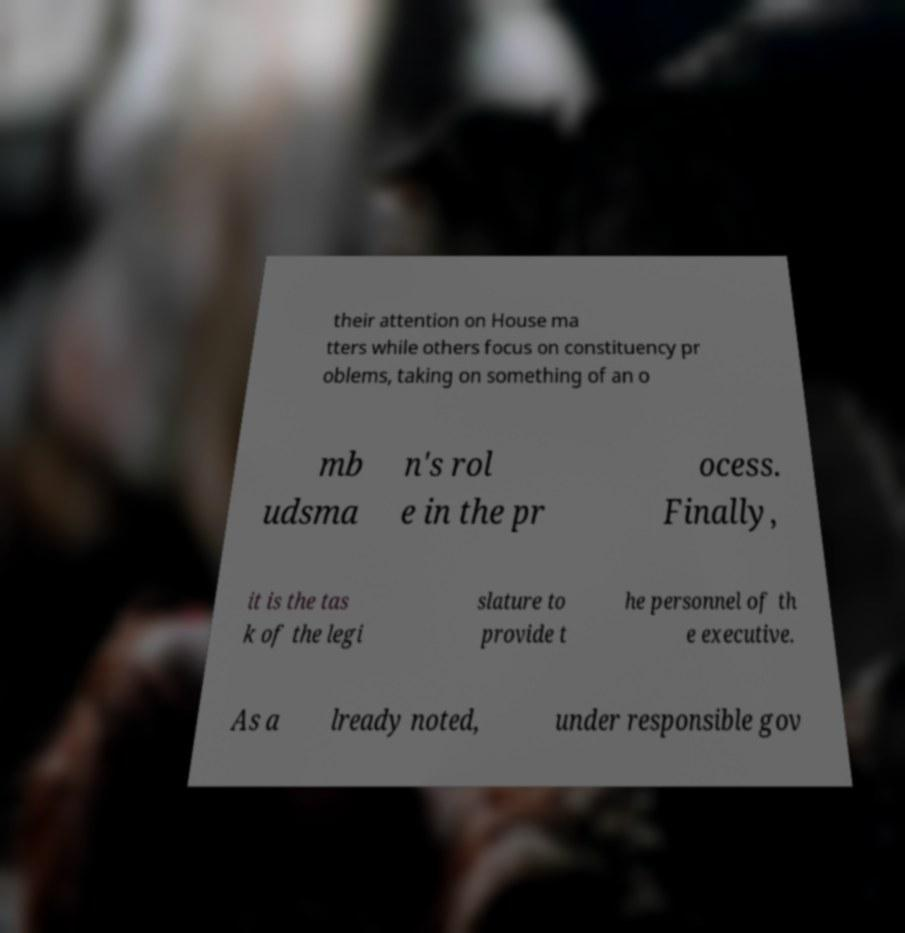Could you extract and type out the text from this image? their attention on House ma tters while others focus on constituency pr oblems, taking on something of an o mb udsma n's rol e in the pr ocess. Finally, it is the tas k of the legi slature to provide t he personnel of th e executive. As a lready noted, under responsible gov 